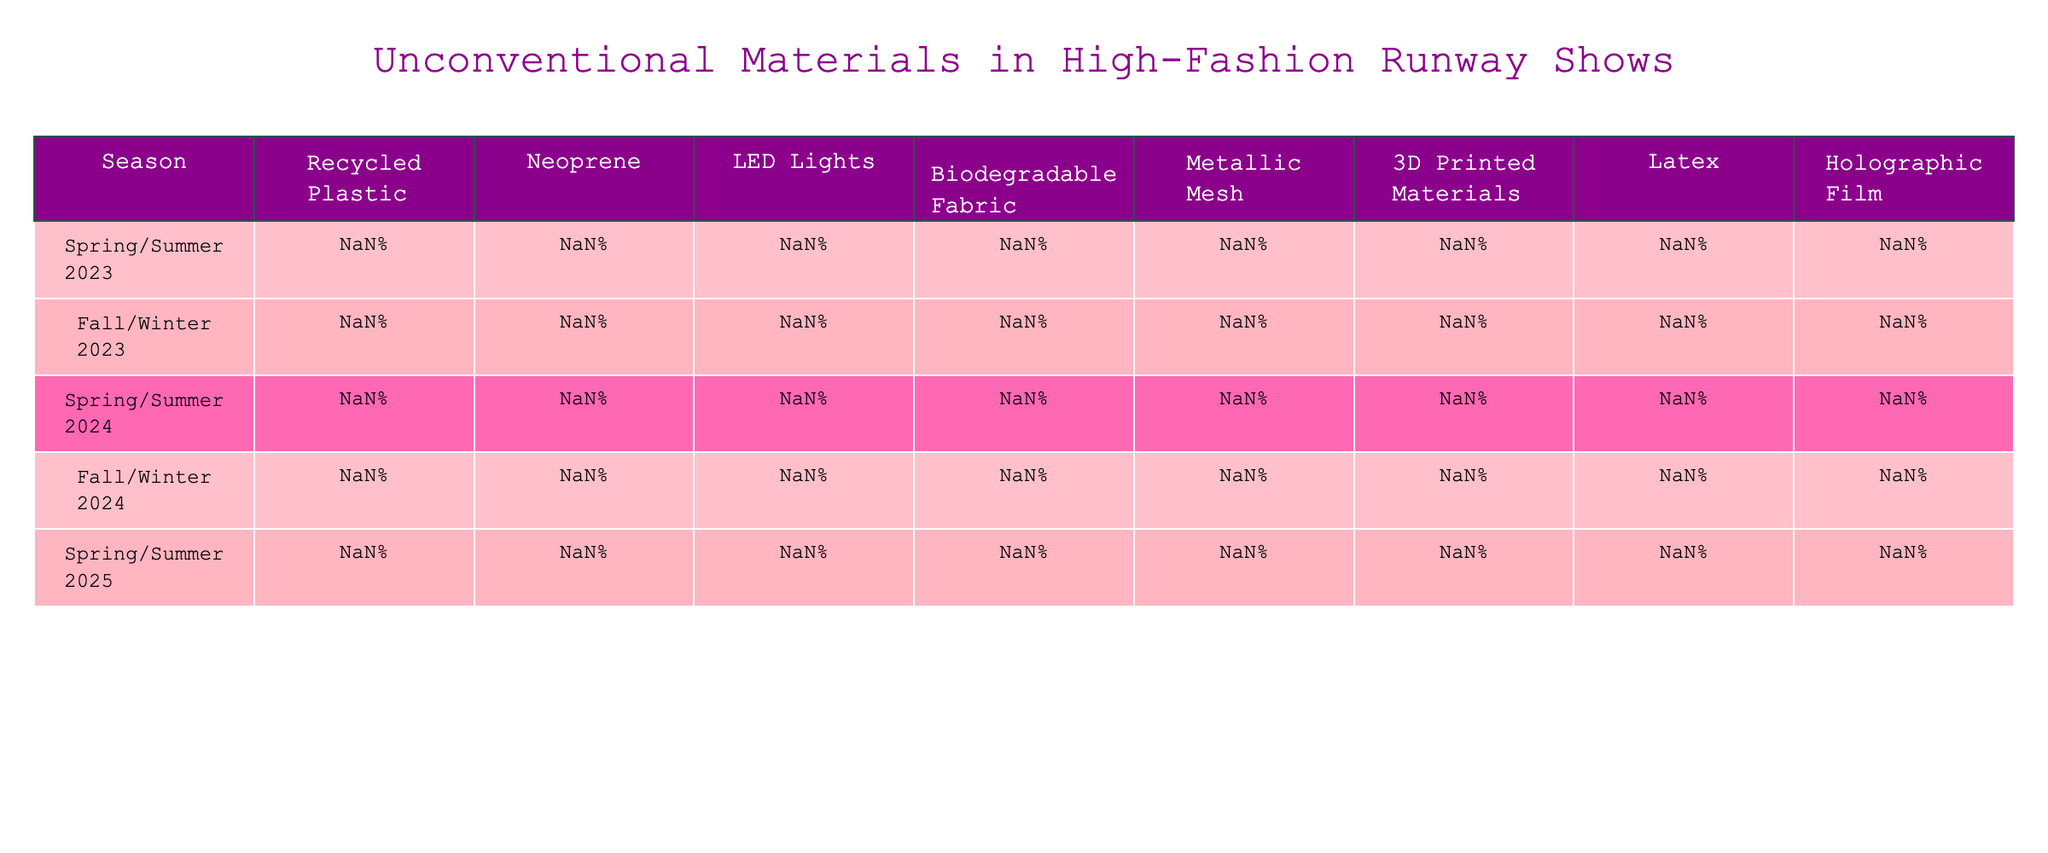What is the percentage of recycled plastic used in Spring/Summer 2024? According to the table, the value for recycled plastic in Spring/Summer 2024 is directly listed as 35%.
Answer: 35% Which seasonal collection used the highest percentage of latex? By examining the table, Fall/Winter 2023 shows a latex usage of 9%, which is higher than the other seasons.
Answer: Fall/Winter 2023 What is the average percentage of LED lights used across all seasons? Summing the percentages: (22% + 18% + 25% + 15% + 30%) = 110%, and dividing by 5 seasons, we get 110% / 5 = 22%.
Answer: 22% Was there an increase in the use of biodegradable fabric from Spring/Summer 2023 to Spring/Summer 2024? Spring/Summer 2023 shows 18% for biodegradable fabric, while Spring/Summer 2024 shows 20%. Since 20% is greater than 18%, it is an increase.
Answer: Yes Which collection had the lowest usage of 3D printed materials? The table indicates that Spring/Summer 2024 had the lowest value at 3%.
Answer: Spring/Summer 2024 What is the total percentage of unconventional materials used in Fall/Winter 2023? Adding the percentages: 12% + 22% + 18% + 10% + 15% + 8% + 9% + 6% = 100%. Therefore, the total is 100%.
Answer: 100% Is there a trend of decreasing use for neoprene from Spring/Summer 2023 to Spring/Summer 2025? The values are: 15% (Spring/Summer 2023), 8% (Spring/Summer 2024), and 5% (Spring/Summer 2025). This shows a decreasing trend over the three seasons.
Answer: Yes What percentage of metallic mesh was used in Fall/Winter 2024 compared to Spring/Summer 2023? Fall/Winter 2024 used 18% of metallic mesh, which is higher than the 7% used in Spring/Summer 2023.
Answer: Higher in Fall/Winter 2024 What percentage of materials used in Spring/Summer 2025 was dedicated to recycled plastic and latex combined? Adding the percentages: 40% (recycled plastic) + 1% (latex) = 41%.
Answer: 41% During which season did biodegradable fabric usage peak? Spring/Summer 2024 shows the highest percentage of biodegradable fabric at 20% compared to all other seasons.
Answer: Spring/Summer 2024 